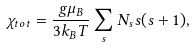<formula> <loc_0><loc_0><loc_500><loc_500>\chi _ { t o t } = \frac { g \mu _ { B } } { 3 k _ { B } T } \sum _ { s } N _ { s } s ( s + 1 ) ,</formula> 